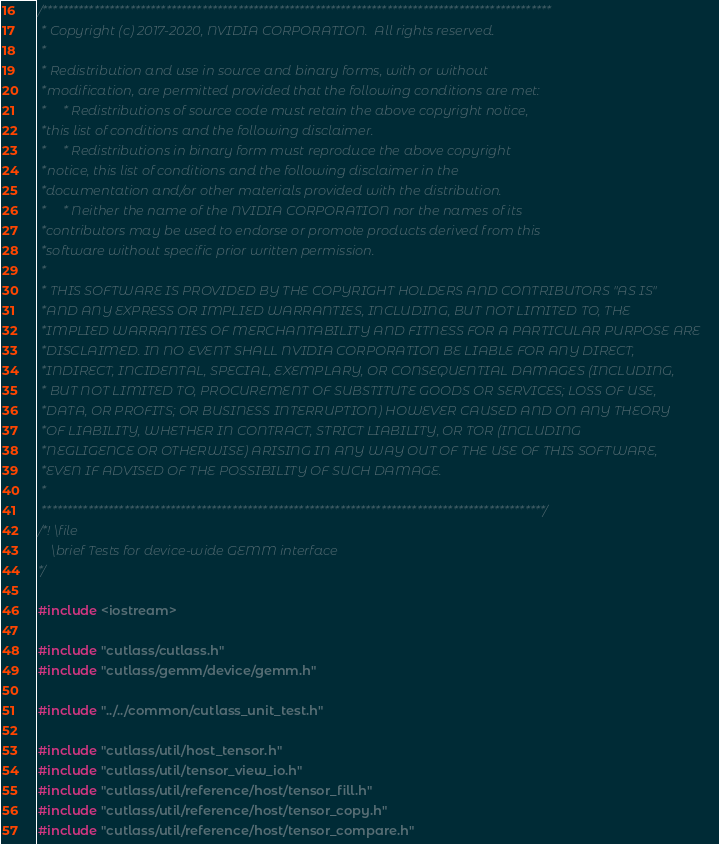Convert code to text. <code><loc_0><loc_0><loc_500><loc_500><_Cuda_>/***************************************************************************************************
 * Copyright (c) 2017-2020, NVIDIA CORPORATION.  All rights reserved.
 *
 * Redistribution and use in source and binary forms, with or without
 *modification, are permitted provided that the following conditions are met:
 *     * Redistributions of source code must retain the above copyright notice,
 *this list of conditions and the following disclaimer.
 *     * Redistributions in binary form must reproduce the above copyright
 *notice, this list of conditions and the following disclaimer in the
 *documentation and/or other materials provided with the distribution.
 *     * Neither the name of the NVIDIA CORPORATION nor the names of its
 *contributors may be used to endorse or promote products derived from this
 *software without specific prior written permission.
 *
 * THIS SOFTWARE IS PROVIDED BY THE COPYRIGHT HOLDERS AND CONTRIBUTORS "AS IS"
 *AND ANY EXPRESS OR IMPLIED WARRANTIES, INCLUDING, BUT NOT LIMITED TO, THE
 *IMPLIED WARRANTIES OF MERCHANTABILITY AND FITNESS FOR A PARTICULAR PURPOSE ARE
 *DISCLAIMED. IN NO EVENT SHALL NVIDIA CORPORATION BE LIABLE FOR ANY DIRECT,
 *INDIRECT, INCIDENTAL, SPECIAL, EXEMPLARY, OR CONSEQUENTIAL DAMAGES (INCLUDING,
 * BUT NOT LIMITED TO, PROCUREMENT OF SUBSTITUTE GOODS OR SERVICES; LOSS OF USE,
 *DATA, OR PROFITS; OR BUSINESS INTERRUPTION) HOWEVER CAUSED AND ON ANY THEORY
 *OF LIABILITY, WHETHER IN CONTRACT, STRICT LIABILITY, OR TOR (INCLUDING
 *NEGLIGENCE OR OTHERWISE) ARISING IN ANY WAY OUT OF THE USE OF THIS SOFTWARE,
 *EVEN IF ADVISED OF THE POSSIBILITY OF SUCH DAMAGE.
 *
 **************************************************************************************************/
/*! \file
    \brief Tests for device-wide GEMM interface
*/

#include <iostream>

#include "cutlass/cutlass.h"
#include "cutlass/gemm/device/gemm.h"

#include "../../common/cutlass_unit_test.h"

#include "cutlass/util/host_tensor.h"
#include "cutlass/util/tensor_view_io.h"
#include "cutlass/util/reference/host/tensor_fill.h"
#include "cutlass/util/reference/host/tensor_copy.h"
#include "cutlass/util/reference/host/tensor_compare.h"</code> 